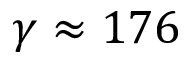Convert formula to latex. <formula><loc_0><loc_0><loc_500><loc_500>\gamma \approx 1 7 6</formula> 